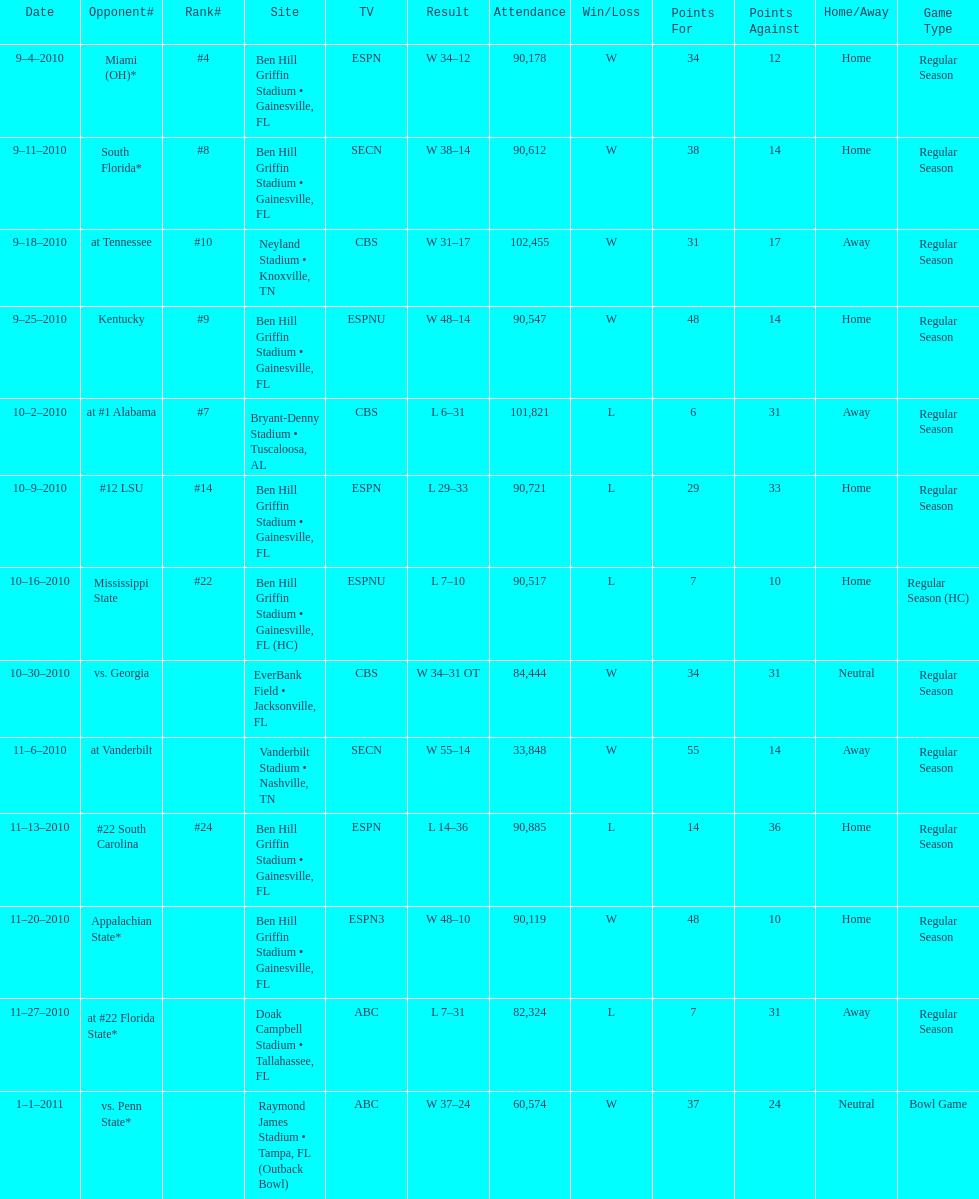How did the scores differ in the most recent game between the two teams? 13 points. 